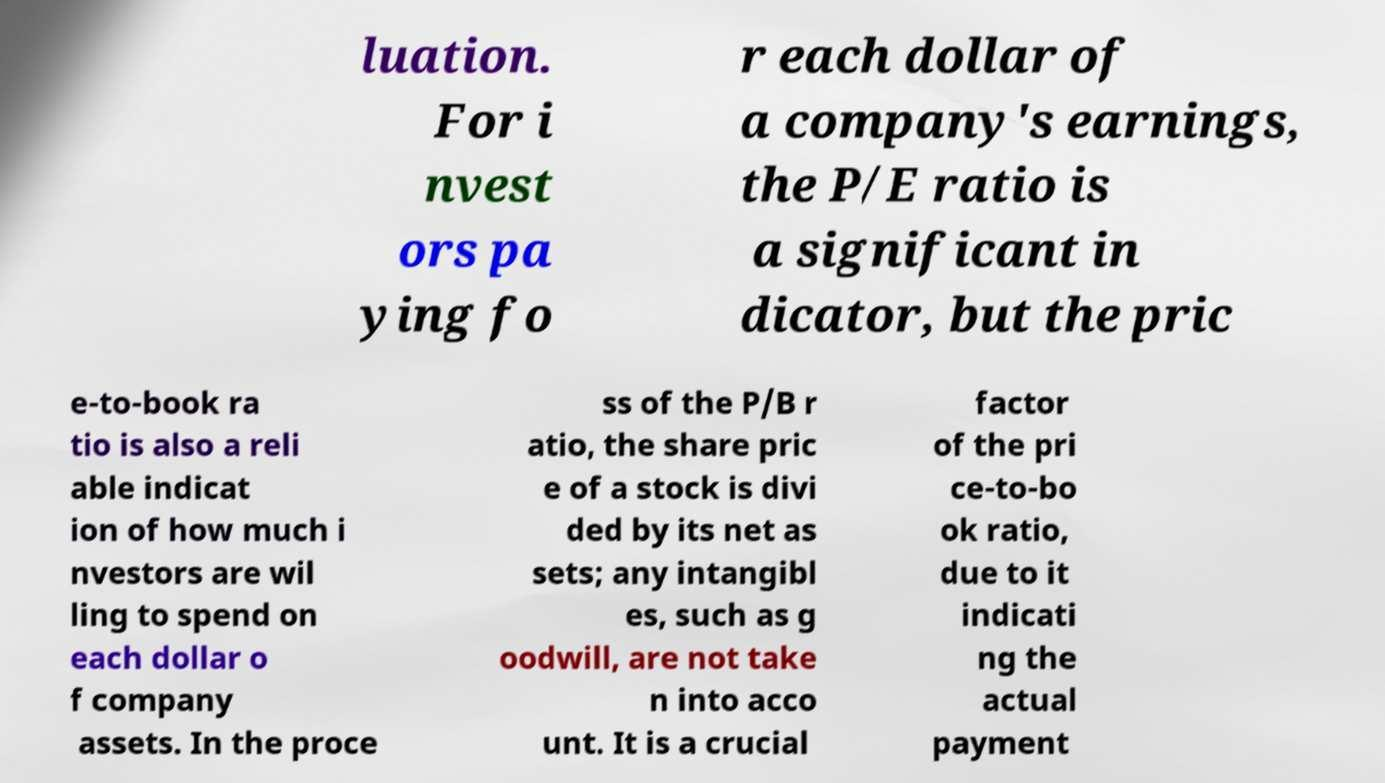Please read and relay the text visible in this image. What does it say? luation. For i nvest ors pa ying fo r each dollar of a company's earnings, the P/E ratio is a significant in dicator, but the pric e-to-book ra tio is also a reli able indicat ion of how much i nvestors are wil ling to spend on each dollar o f company assets. In the proce ss of the P/B r atio, the share pric e of a stock is divi ded by its net as sets; any intangibl es, such as g oodwill, are not take n into acco unt. It is a crucial factor of the pri ce-to-bo ok ratio, due to it indicati ng the actual payment 